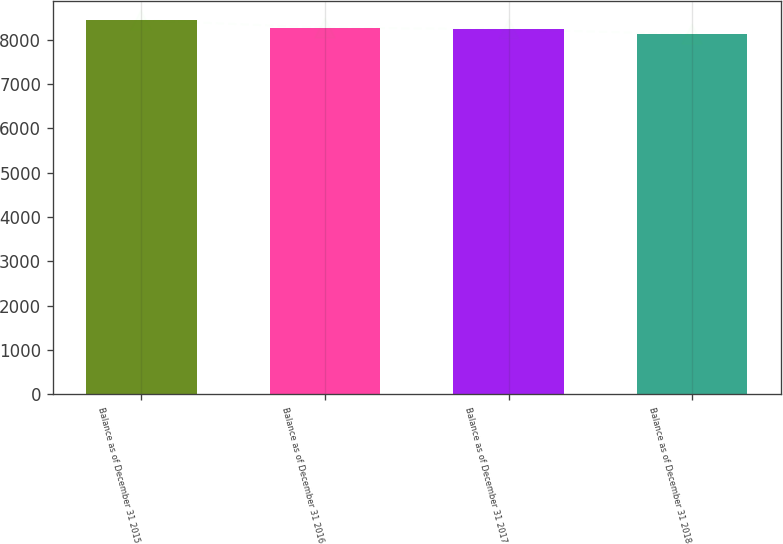Convert chart to OTSL. <chart><loc_0><loc_0><loc_500><loc_500><bar_chart><fcel>Balance as of December 31 2015<fcel>Balance as of December 31 2016<fcel>Balance as of December 31 2017<fcel>Balance as of December 31 2018<nl><fcel>8441<fcel>8269.8<fcel>8238<fcel>8123<nl></chart> 